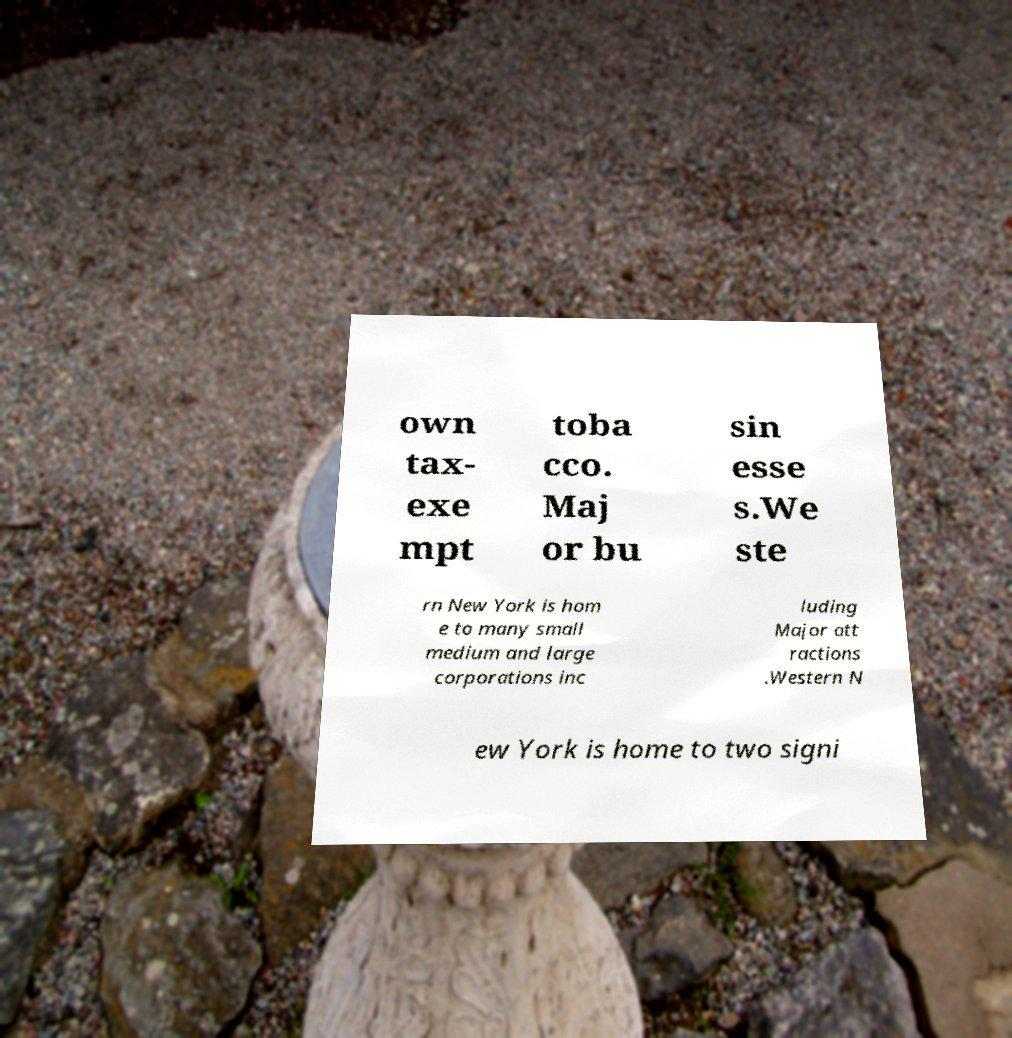Can you accurately transcribe the text from the provided image for me? own tax- exe mpt toba cco. Maj or bu sin esse s.We ste rn New York is hom e to many small medium and large corporations inc luding Major att ractions .Western N ew York is home to two signi 